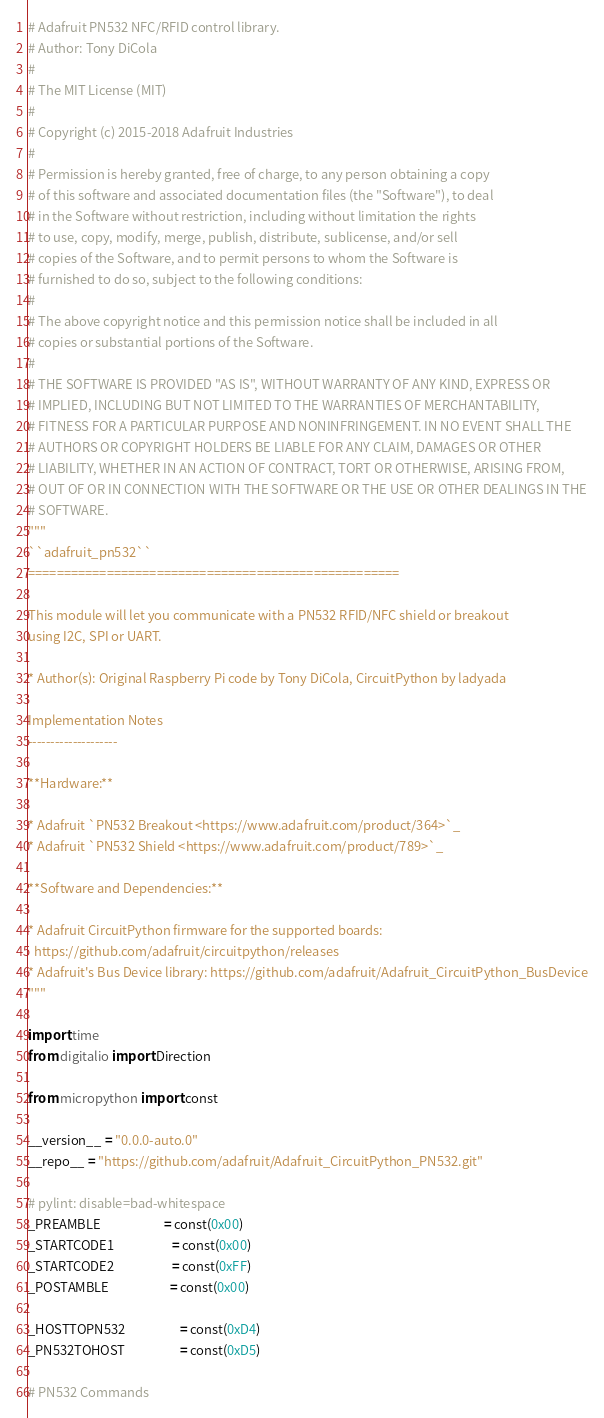<code> <loc_0><loc_0><loc_500><loc_500><_Python_># Adafruit PN532 NFC/RFID control library.
# Author: Tony DiCola
#
# The MIT License (MIT)
#
# Copyright (c) 2015-2018 Adafruit Industries
#
# Permission is hereby granted, free of charge, to any person obtaining a copy
# of this software and associated documentation files (the "Software"), to deal
# in the Software without restriction, including without limitation the rights
# to use, copy, modify, merge, publish, distribute, sublicense, and/or sell
# copies of the Software, and to permit persons to whom the Software is
# furnished to do so, subject to the following conditions:
#
# The above copyright notice and this permission notice shall be included in all
# copies or substantial portions of the Software.
#
# THE SOFTWARE IS PROVIDED "AS IS", WITHOUT WARRANTY OF ANY KIND, EXPRESS OR
# IMPLIED, INCLUDING BUT NOT LIMITED TO THE WARRANTIES OF MERCHANTABILITY,
# FITNESS FOR A PARTICULAR PURPOSE AND NONINFRINGEMENT. IN NO EVENT SHALL THE
# AUTHORS OR COPYRIGHT HOLDERS BE LIABLE FOR ANY CLAIM, DAMAGES OR OTHER
# LIABILITY, WHETHER IN AN ACTION OF CONTRACT, TORT OR OTHERWISE, ARISING FROM,
# OUT OF OR IN CONNECTION WITH THE SOFTWARE OR THE USE OR OTHER DEALINGS IN THE
# SOFTWARE.
"""
``adafruit_pn532``
====================================================

This module will let you communicate with a PN532 RFID/NFC shield or breakout
using I2C, SPI or UART.

* Author(s): Original Raspberry Pi code by Tony DiCola, CircuitPython by ladyada

Implementation Notes
--------------------

**Hardware:**

* Adafruit `PN532 Breakout <https://www.adafruit.com/product/364>`_
* Adafruit `PN532 Shield <https://www.adafruit.com/product/789>`_

**Software and Dependencies:**

* Adafruit CircuitPython firmware for the supported boards:
  https://github.com/adafruit/circuitpython/releases
* Adafruit's Bus Device library: https://github.com/adafruit/Adafruit_CircuitPython_BusDevice
"""

import time
from digitalio import Direction

from micropython import const

__version__ = "0.0.0-auto.0"
__repo__ = "https://github.com/adafruit/Adafruit_CircuitPython_PN532.git"

# pylint: disable=bad-whitespace
_PREAMBLE                      = const(0x00)
_STARTCODE1                    = const(0x00)
_STARTCODE2                    = const(0xFF)
_POSTAMBLE                     = const(0x00)

_HOSTTOPN532                   = const(0xD4)
_PN532TOHOST                   = const(0xD5)

# PN532 Commands</code> 